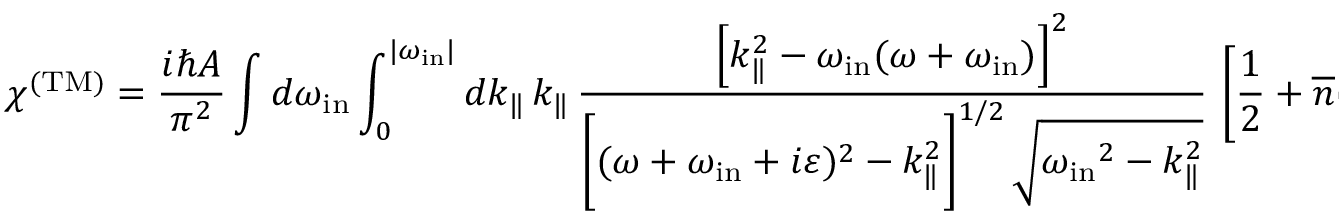Convert formula to latex. <formula><loc_0><loc_0><loc_500><loc_500>\chi ^ { ( T M ) } = { \frac { i \hbar { A } } { \pi ^ { 2 } } } \int d \omega _ { i n } \int _ { 0 } ^ { | \omega _ { i n } | } d k _ { \| } \, k _ { \| } \, \frac { \left [ k _ { \| } ^ { 2 } - \omega _ { i n } ( \omega + \omega _ { i n } ) \right ] ^ { 2 } } { \left [ ( \omega + \omega _ { i n } + i \varepsilon ) ^ { 2 } - k _ { \| } ^ { 2 } \right ] ^ { 1 / 2 } \, \sqrt { { \omega _ { i n } } ^ { 2 } - k _ { \| } ^ { 2 } } } \, \left [ { \frac { 1 } { 2 } } + { \overline { n } } ( | \omega _ { i n } | ) \right ] .</formula> 